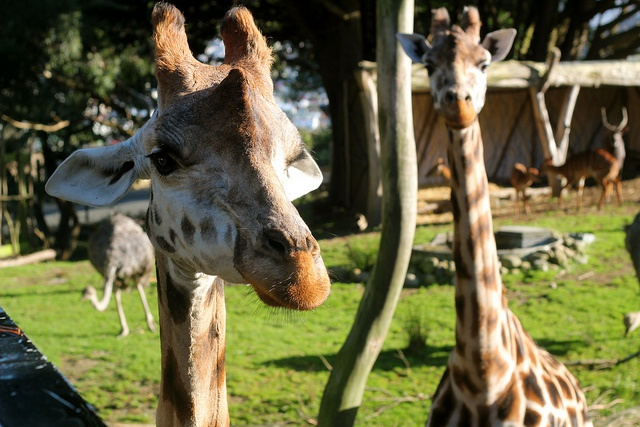Describe the objects in this image and their specific colors. I can see giraffe in black, gray, ivory, and tan tones, giraffe in black, ivory, tan, and maroon tones, and bird in black, darkgray, and tan tones in this image. 